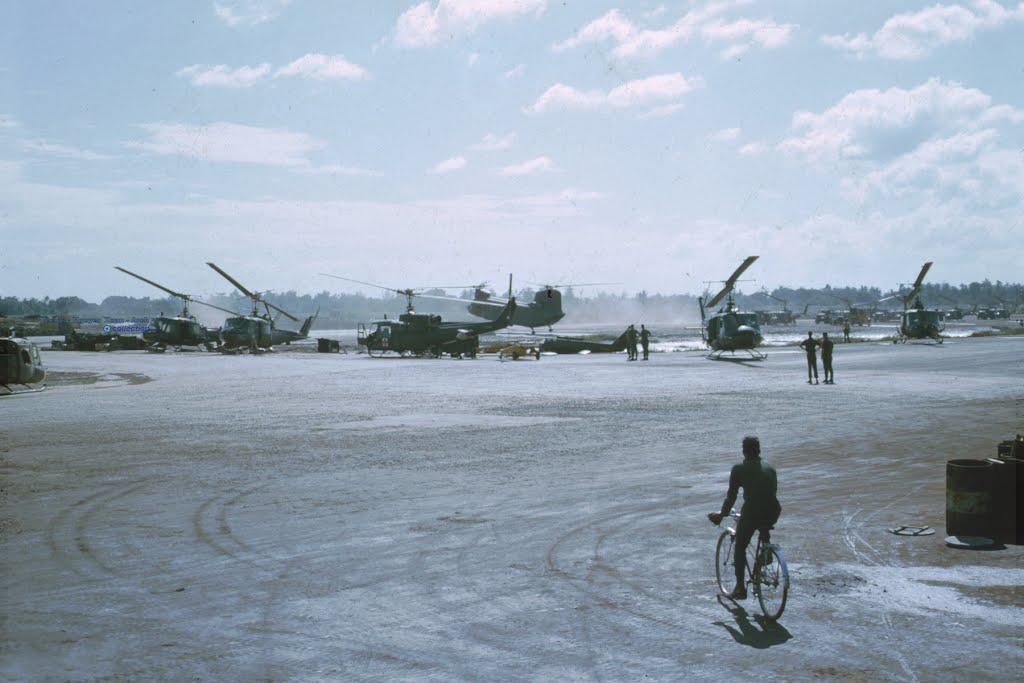Describe this image in one or two sentences. This picture is taken from the outside of the city. In this image, on the right side, we can a man riding a bicycle. On the right side, we can also see few water drums. On the right side, we can also see a few men are standing. In the background, we can see few helicopters, trees, plants and a smoke. At the top, we can see a sky which is a bit cloudy, at the bottom, we can see a land with some stones. 